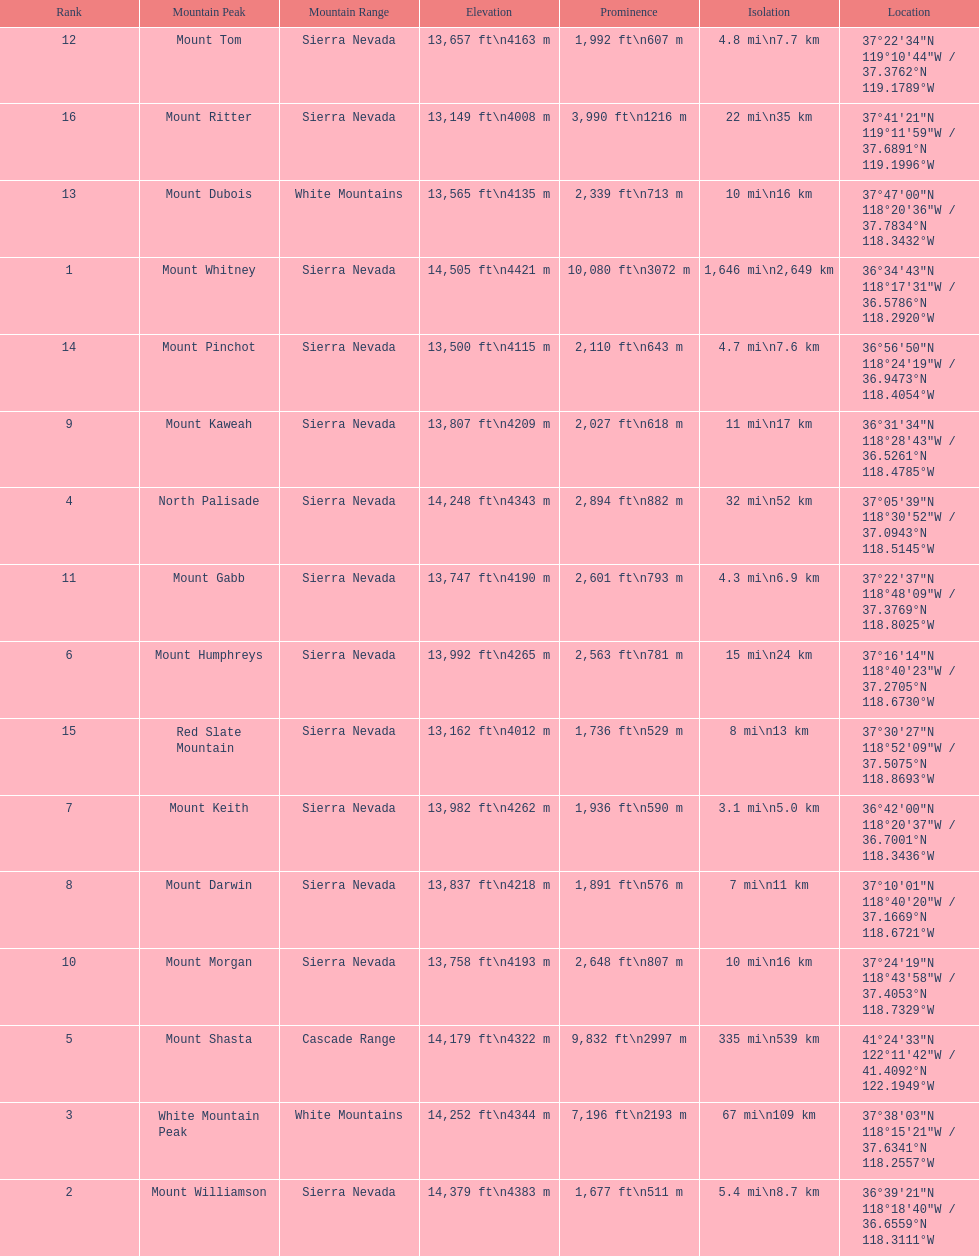Which mountain peak has the most isolation? Mount Whitney. 